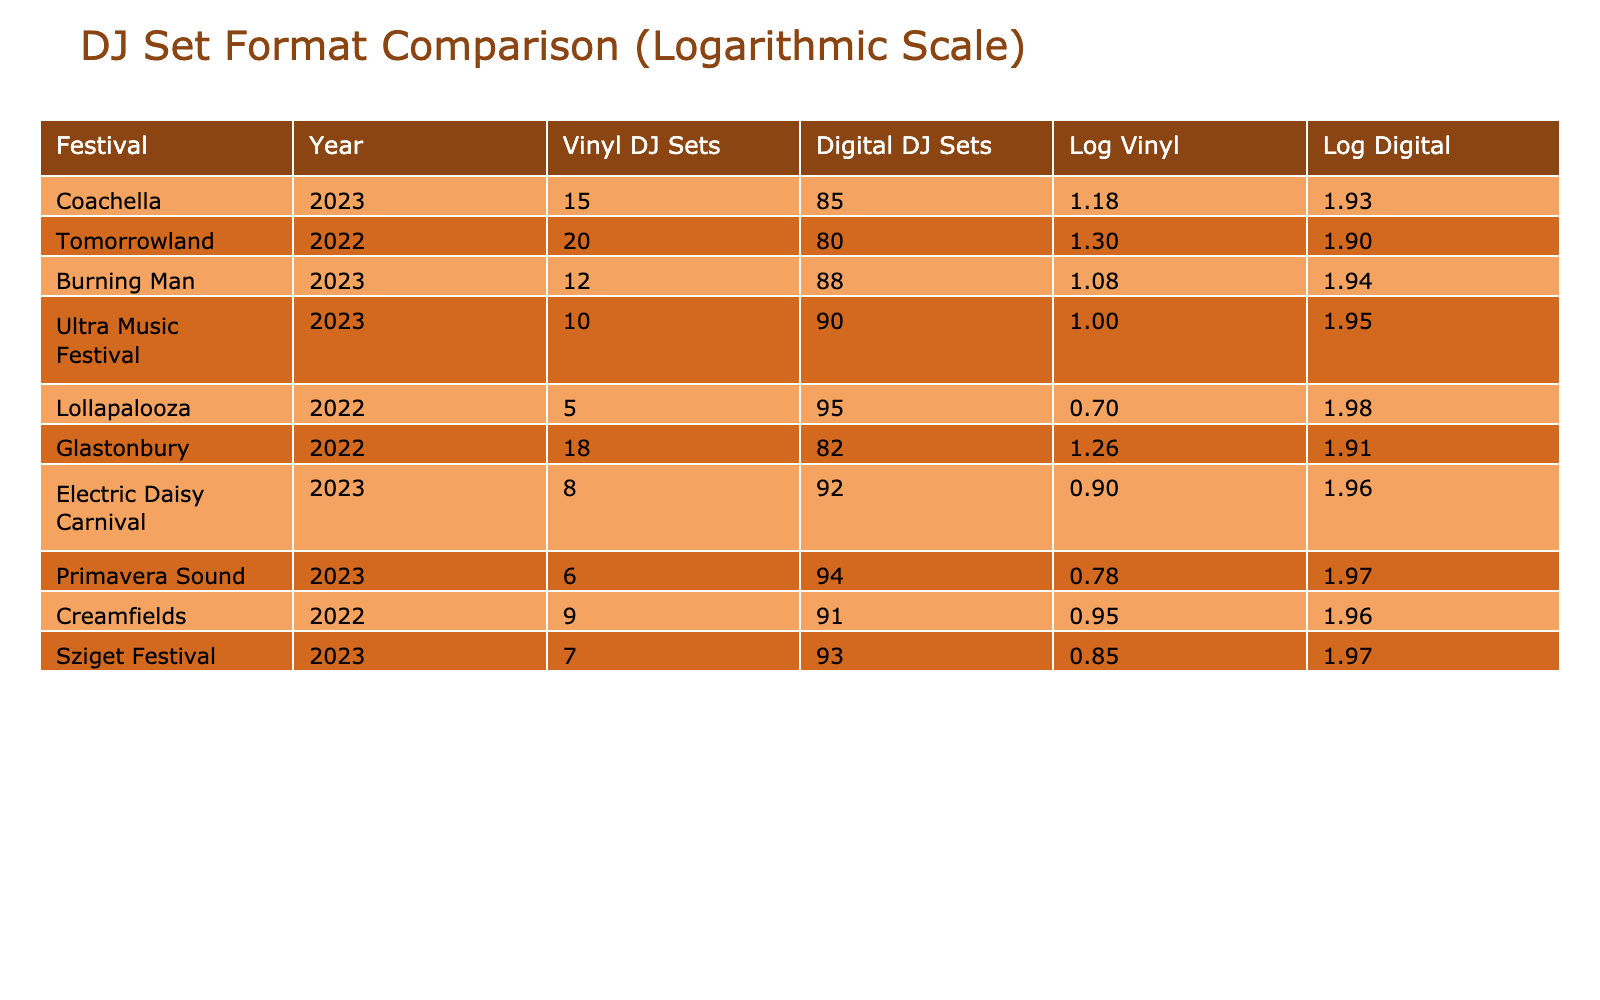What is the total number of vinyl DJ sets at Coachella in 2023? The table directly indicates that the number of vinyl DJ sets at Coachella in 2023 is listed under the "Vinyl DJ Sets" column. The value there is 15.
Answer: 15 How many more digital DJ sets were there than vinyl DJ sets at Tomorrowland in 2022? At Tomorrowland in 2022, there were 20 vinyl DJ sets and 80 digital DJ sets. The difference is 80 - 20 = 60.
Answer: 60 Which festival had the highest number of vinyl DJ sets and what was that number? By scanning the "Vinyl DJ Sets" column, the highest number can be identified. Tomorrowland in 2022 had 20 vinyl DJ sets, which is the maximum in the provided data.
Answer: 20 Is it true that Glastonbury in 2022 had more vinyl DJ sets than Lollapalooza in 2022? Comparing the vinyl DJ sets for both festivals: Glastonbury had 18 vinyl DJ sets while Lollapalooza had only 5. Since 18 is greater than 5, the statement is true.
Answer: Yes What is the average number of vinyl DJ sets across all festivals listed in the table? First, sum the vinyl DJ sets: 15 + 20 + 12 + 10 + 5 + 18 + 8 + 6 + 9 + 7 =  110. There are 10 festivals, so the average is 110 / 10 = 11.
Answer: 11 How many total DJ sets (both vinyl and digital) were performed at Electric Daisy Carnival in 2023? The total DJ sets for Electric Daisy Carnival can be calculated by adding the vinyl and digital sets together: 8 vinyl sets + 92 digital sets = 100 total sets.
Answer: 100 Did any festival in 2023 have more vinyl DJ sets than the same year's digital DJ sets? In 2023, both Burning Man and Ultra Music Festival had lower vinyl sets (12 and 10 respectively) compared to their digital sets (88 and 90 respectively). Therefore, no festival in 2023 had more vinyl than digital sets.
Answer: No What is the difference in the total number of vinyl DJ sets between Burning Man 2023 and Glastonbury 2022? For Burning Man, the number of vinyl DJ sets is 12, and for Glastonbury, it is 18. The difference can be found by subtracting 12 from 18, resulting in 6.
Answer: 6 What is the ratio of vinyl DJ sets to digital DJ sets for Sziget Festival in 2023? The number of vinyl DJ sets at Sziget is 7 and digital is 93. The ratio can be expressed as 7:93. To simplify, divide both numbers by their greatest common divisor (which is 1 here), resulting in the same ratio.
Answer: 7:93 